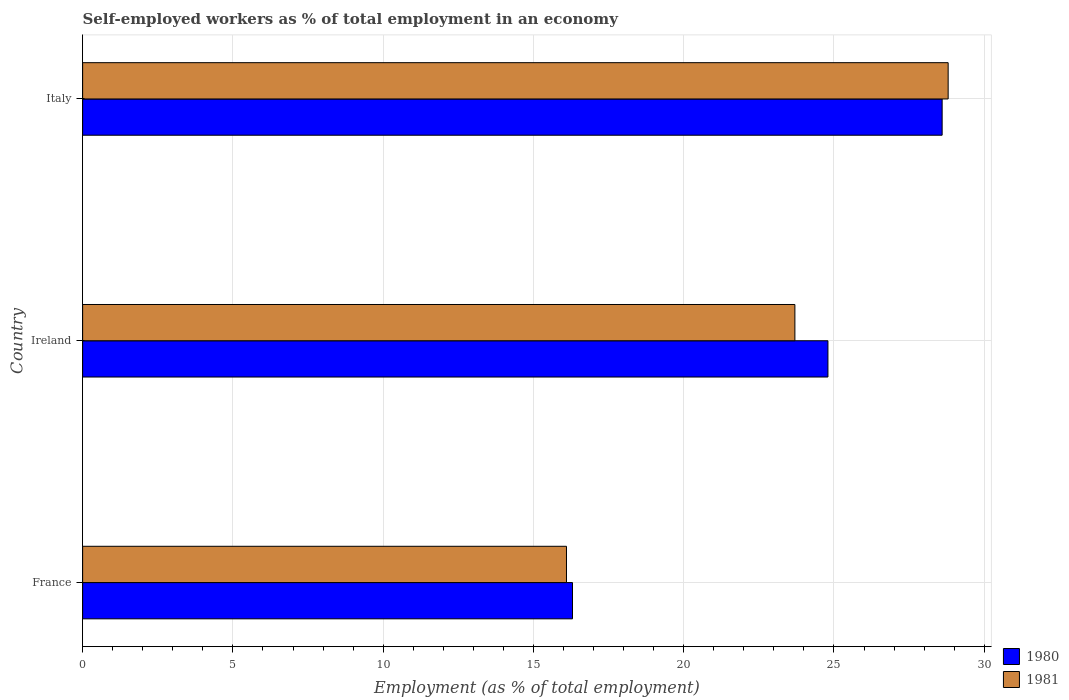Are the number of bars per tick equal to the number of legend labels?
Give a very brief answer. Yes. What is the label of the 3rd group of bars from the top?
Your response must be concise. France. What is the percentage of self-employed workers in 1980 in France?
Ensure brevity in your answer.  16.3. Across all countries, what is the maximum percentage of self-employed workers in 1980?
Ensure brevity in your answer.  28.6. Across all countries, what is the minimum percentage of self-employed workers in 1980?
Offer a terse response. 16.3. In which country was the percentage of self-employed workers in 1980 maximum?
Keep it short and to the point. Italy. In which country was the percentage of self-employed workers in 1980 minimum?
Your answer should be compact. France. What is the total percentage of self-employed workers in 1980 in the graph?
Your answer should be compact. 69.7. What is the difference between the percentage of self-employed workers in 1981 in France and that in Ireland?
Give a very brief answer. -7.6. What is the difference between the percentage of self-employed workers in 1981 in France and the percentage of self-employed workers in 1980 in Ireland?
Your answer should be compact. -8.7. What is the average percentage of self-employed workers in 1980 per country?
Your response must be concise. 23.23. What is the difference between the percentage of self-employed workers in 1980 and percentage of self-employed workers in 1981 in Italy?
Your response must be concise. -0.2. In how many countries, is the percentage of self-employed workers in 1980 greater than 7 %?
Your response must be concise. 3. What is the ratio of the percentage of self-employed workers in 1981 in Ireland to that in Italy?
Offer a very short reply. 0.82. Is the percentage of self-employed workers in 1980 in France less than that in Ireland?
Ensure brevity in your answer.  Yes. What is the difference between the highest and the second highest percentage of self-employed workers in 1981?
Keep it short and to the point. 5.1. What is the difference between the highest and the lowest percentage of self-employed workers in 1980?
Ensure brevity in your answer.  12.3. Is the sum of the percentage of self-employed workers in 1980 in France and Italy greater than the maximum percentage of self-employed workers in 1981 across all countries?
Provide a succinct answer. Yes. Are all the bars in the graph horizontal?
Ensure brevity in your answer.  Yes. Are the values on the major ticks of X-axis written in scientific E-notation?
Offer a terse response. No. Does the graph contain grids?
Your answer should be compact. Yes. What is the title of the graph?
Provide a succinct answer. Self-employed workers as % of total employment in an economy. What is the label or title of the X-axis?
Make the answer very short. Employment (as % of total employment). What is the Employment (as % of total employment) of 1980 in France?
Your response must be concise. 16.3. What is the Employment (as % of total employment) of 1981 in France?
Give a very brief answer. 16.1. What is the Employment (as % of total employment) of 1980 in Ireland?
Give a very brief answer. 24.8. What is the Employment (as % of total employment) of 1981 in Ireland?
Offer a terse response. 23.7. What is the Employment (as % of total employment) of 1980 in Italy?
Your answer should be compact. 28.6. What is the Employment (as % of total employment) in 1981 in Italy?
Your response must be concise. 28.8. Across all countries, what is the maximum Employment (as % of total employment) of 1980?
Your answer should be very brief. 28.6. Across all countries, what is the maximum Employment (as % of total employment) of 1981?
Keep it short and to the point. 28.8. Across all countries, what is the minimum Employment (as % of total employment) of 1980?
Your answer should be compact. 16.3. Across all countries, what is the minimum Employment (as % of total employment) in 1981?
Give a very brief answer. 16.1. What is the total Employment (as % of total employment) of 1980 in the graph?
Your answer should be compact. 69.7. What is the total Employment (as % of total employment) in 1981 in the graph?
Keep it short and to the point. 68.6. What is the difference between the Employment (as % of total employment) of 1980 in France and that in Italy?
Offer a very short reply. -12.3. What is the difference between the Employment (as % of total employment) in 1981 in Ireland and that in Italy?
Keep it short and to the point. -5.1. What is the average Employment (as % of total employment) in 1980 per country?
Make the answer very short. 23.23. What is the average Employment (as % of total employment) in 1981 per country?
Give a very brief answer. 22.87. What is the difference between the Employment (as % of total employment) in 1980 and Employment (as % of total employment) in 1981 in Ireland?
Provide a short and direct response. 1.1. What is the difference between the Employment (as % of total employment) in 1980 and Employment (as % of total employment) in 1981 in Italy?
Your response must be concise. -0.2. What is the ratio of the Employment (as % of total employment) in 1980 in France to that in Ireland?
Offer a terse response. 0.66. What is the ratio of the Employment (as % of total employment) in 1981 in France to that in Ireland?
Provide a succinct answer. 0.68. What is the ratio of the Employment (as % of total employment) of 1980 in France to that in Italy?
Your response must be concise. 0.57. What is the ratio of the Employment (as % of total employment) of 1981 in France to that in Italy?
Make the answer very short. 0.56. What is the ratio of the Employment (as % of total employment) in 1980 in Ireland to that in Italy?
Ensure brevity in your answer.  0.87. What is the ratio of the Employment (as % of total employment) of 1981 in Ireland to that in Italy?
Your response must be concise. 0.82. What is the difference between the highest and the second highest Employment (as % of total employment) of 1980?
Provide a short and direct response. 3.8. What is the difference between the highest and the second highest Employment (as % of total employment) in 1981?
Your response must be concise. 5.1. What is the difference between the highest and the lowest Employment (as % of total employment) in 1980?
Your answer should be compact. 12.3. What is the difference between the highest and the lowest Employment (as % of total employment) of 1981?
Your response must be concise. 12.7. 